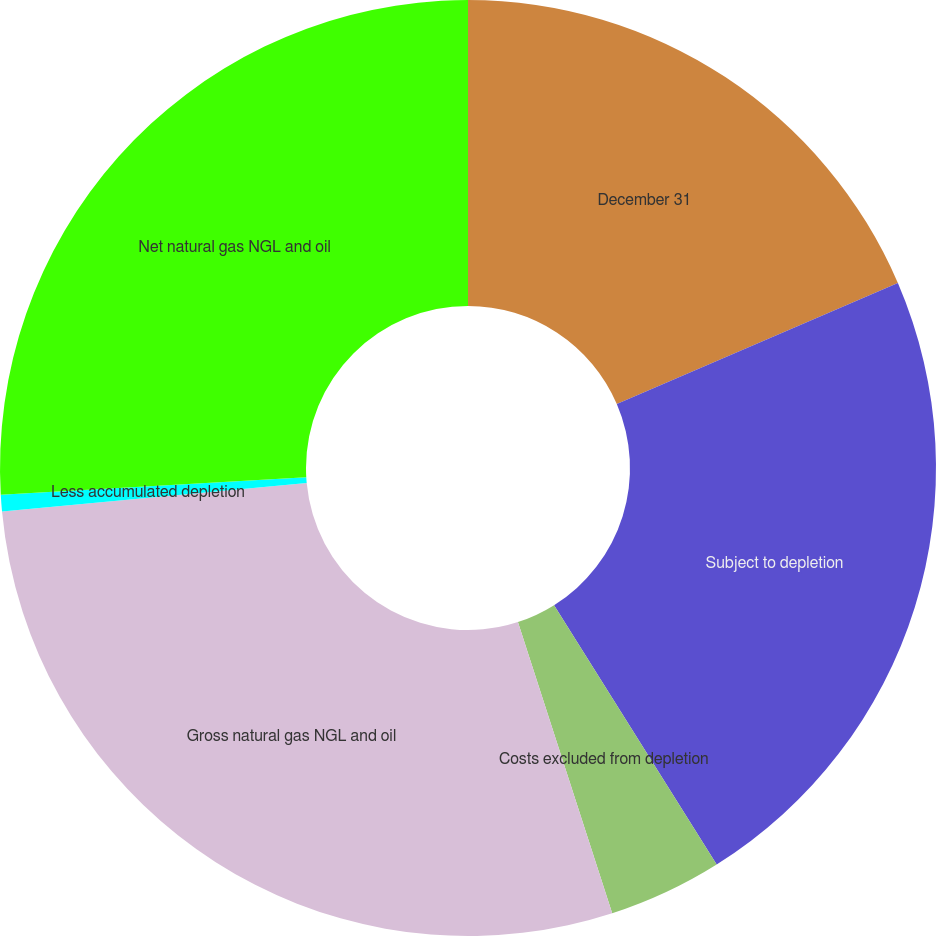<chart> <loc_0><loc_0><loc_500><loc_500><pie_chart><fcel>December 31<fcel>Subject to depletion<fcel>Costs excluded from depletion<fcel>Gross natural gas NGL and oil<fcel>Less accumulated depletion<fcel>Net natural gas NGL and oil<nl><fcel>18.53%<fcel>22.55%<fcel>3.93%<fcel>28.5%<fcel>0.57%<fcel>25.91%<nl></chart> 